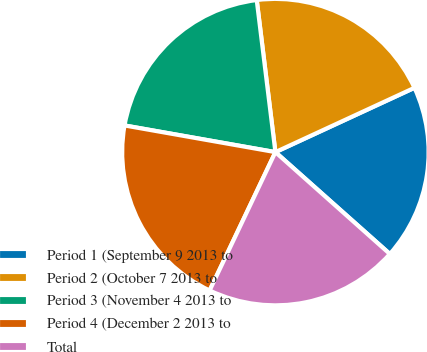Convert chart to OTSL. <chart><loc_0><loc_0><loc_500><loc_500><pie_chart><fcel>Period 1 (September 9 2013 to<fcel>Period 2 (October 7 2013 to<fcel>Period 3 (November 4 2013 to<fcel>Period 4 (December 2 2013 to<fcel>Total<nl><fcel>18.47%<fcel>20.05%<fcel>20.27%<fcel>20.72%<fcel>20.49%<nl></chart> 